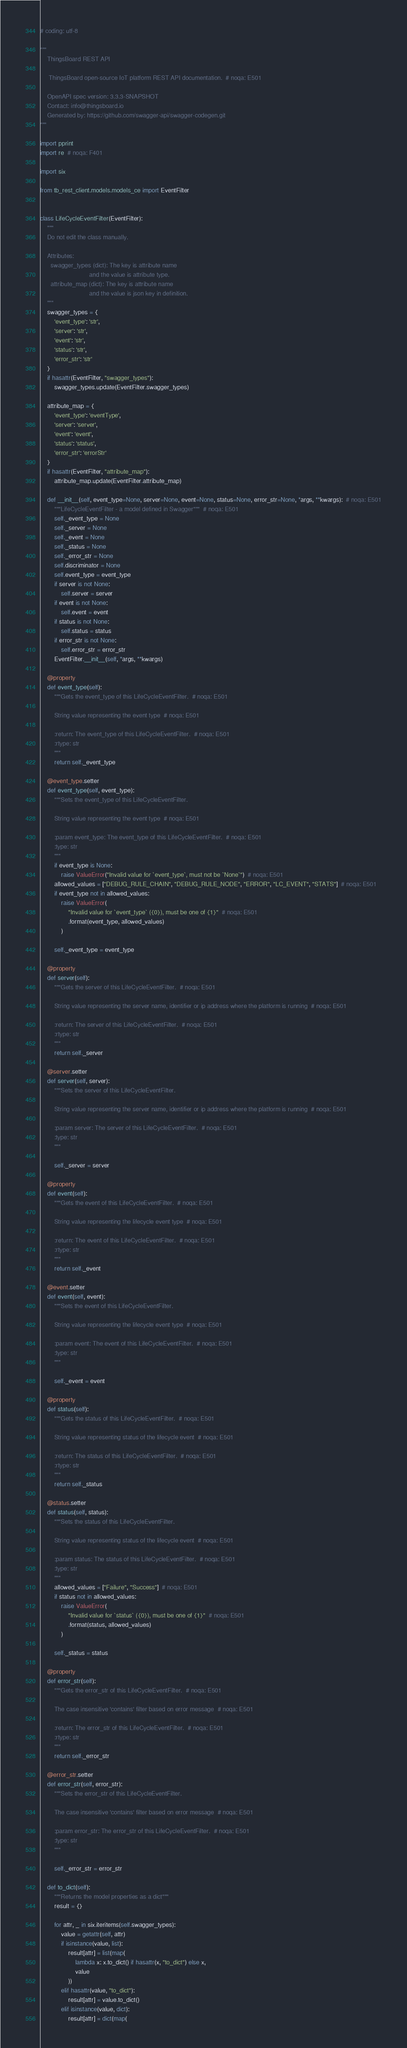<code> <loc_0><loc_0><loc_500><loc_500><_Python_># coding: utf-8

"""
    ThingsBoard REST API

     ThingsBoard open-source IoT platform REST API documentation.  # noqa: E501

    OpenAPI spec version: 3.3.3-SNAPSHOT
    Contact: info@thingsboard.io
    Generated by: https://github.com/swagger-api/swagger-codegen.git
"""

import pprint
import re  # noqa: F401

import six

from tb_rest_client.models.models_ce import EventFilter


class LifeCycleEventFilter(EventFilter):
    """
    Do not edit the class manually.

    Attributes:
      swagger_types (dict): The key is attribute name
                            and the value is attribute type.
      attribute_map (dict): The key is attribute name
                            and the value is json key in definition.
    """
    swagger_types = {
        'event_type': 'str',
        'server': 'str',
        'event': 'str',
        'status': 'str',
        'error_str': 'str'
    }
    if hasattr(EventFilter, "swagger_types"):
        swagger_types.update(EventFilter.swagger_types)

    attribute_map = {
        'event_type': 'eventType',
        'server': 'server',
        'event': 'event',
        'status': 'status',
        'error_str': 'errorStr'
    }
    if hasattr(EventFilter, "attribute_map"):
        attribute_map.update(EventFilter.attribute_map)

    def __init__(self, event_type=None, server=None, event=None, status=None, error_str=None, *args, **kwargs):  # noqa: E501
        """LifeCycleEventFilter - a model defined in Swagger"""  # noqa: E501
        self._event_type = None
        self._server = None
        self._event = None
        self._status = None
        self._error_str = None
        self.discriminator = None
        self.event_type = event_type
        if server is not None:
            self.server = server
        if event is not None:
            self.event = event
        if status is not None:
            self.status = status
        if error_str is not None:
            self.error_str = error_str
        EventFilter.__init__(self, *args, **kwargs)

    @property
    def event_type(self):
        """Gets the event_type of this LifeCycleEventFilter.  # noqa: E501

        String value representing the event type  # noqa: E501

        :return: The event_type of this LifeCycleEventFilter.  # noqa: E501
        :rtype: str
        """
        return self._event_type

    @event_type.setter
    def event_type(self, event_type):
        """Sets the event_type of this LifeCycleEventFilter.

        String value representing the event type  # noqa: E501

        :param event_type: The event_type of this LifeCycleEventFilter.  # noqa: E501
        :type: str
        """
        if event_type is None:
            raise ValueError("Invalid value for `event_type`, must not be `None`")  # noqa: E501
        allowed_values = ["DEBUG_RULE_CHAIN", "DEBUG_RULE_NODE", "ERROR", "LC_EVENT", "STATS"]  # noqa: E501
        if event_type not in allowed_values:
            raise ValueError(
                "Invalid value for `event_type` ({0}), must be one of {1}"  # noqa: E501
                .format(event_type, allowed_values)
            )

        self._event_type = event_type

    @property
    def server(self):
        """Gets the server of this LifeCycleEventFilter.  # noqa: E501

        String value representing the server name, identifier or ip address where the platform is running  # noqa: E501

        :return: The server of this LifeCycleEventFilter.  # noqa: E501
        :rtype: str
        """
        return self._server

    @server.setter
    def server(self, server):
        """Sets the server of this LifeCycleEventFilter.

        String value representing the server name, identifier or ip address where the platform is running  # noqa: E501

        :param server: The server of this LifeCycleEventFilter.  # noqa: E501
        :type: str
        """

        self._server = server

    @property
    def event(self):
        """Gets the event of this LifeCycleEventFilter.  # noqa: E501

        String value representing the lifecycle event type  # noqa: E501

        :return: The event of this LifeCycleEventFilter.  # noqa: E501
        :rtype: str
        """
        return self._event

    @event.setter
    def event(self, event):
        """Sets the event of this LifeCycleEventFilter.

        String value representing the lifecycle event type  # noqa: E501

        :param event: The event of this LifeCycleEventFilter.  # noqa: E501
        :type: str
        """

        self._event = event

    @property
    def status(self):
        """Gets the status of this LifeCycleEventFilter.  # noqa: E501

        String value representing status of the lifecycle event  # noqa: E501

        :return: The status of this LifeCycleEventFilter.  # noqa: E501
        :rtype: str
        """
        return self._status

    @status.setter
    def status(self, status):
        """Sets the status of this LifeCycleEventFilter.

        String value representing status of the lifecycle event  # noqa: E501

        :param status: The status of this LifeCycleEventFilter.  # noqa: E501
        :type: str
        """
        allowed_values = ["Failure", "Success"]  # noqa: E501
        if status not in allowed_values:
            raise ValueError(
                "Invalid value for `status` ({0}), must be one of {1}"  # noqa: E501
                .format(status, allowed_values)
            )

        self._status = status

    @property
    def error_str(self):
        """Gets the error_str of this LifeCycleEventFilter.  # noqa: E501

        The case insensitive 'contains' filter based on error message  # noqa: E501

        :return: The error_str of this LifeCycleEventFilter.  # noqa: E501
        :rtype: str
        """
        return self._error_str

    @error_str.setter
    def error_str(self, error_str):
        """Sets the error_str of this LifeCycleEventFilter.

        The case insensitive 'contains' filter based on error message  # noqa: E501

        :param error_str: The error_str of this LifeCycleEventFilter.  # noqa: E501
        :type: str
        """

        self._error_str = error_str

    def to_dict(self):
        """Returns the model properties as a dict"""
        result = {}

        for attr, _ in six.iteritems(self.swagger_types):
            value = getattr(self, attr)
            if isinstance(value, list):
                result[attr] = list(map(
                    lambda x: x.to_dict() if hasattr(x, "to_dict") else x,
                    value
                ))
            elif hasattr(value, "to_dict"):
                result[attr] = value.to_dict()
            elif isinstance(value, dict):
                result[attr] = dict(map(</code> 